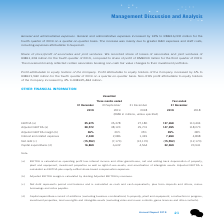According to Tencent's financial document, How is the adjusted EBITDA margin calculated? Adjusted EBITDA margin is calculated by dividing Adjusted EBITDA by revenues.. The document states: "(b) Adjusted EBITDA margin is calculated by dividing Adjusted EBITDA by revenues...." Also, What is adjusted EBITDA calculated as? Adjusted EBITDA is calculated as EBITDA plus equity-settled share-based compensation expenses.. The document states: "use assets, and amortisation of intangible assets. Adjusted EBITDA is calculated as EBITDA plus equity-settled share-based compensation expenses. (b) ..." Also, What does capital expenditures consist of? Capital expenditures consist of additions (excluding business combinations) to property, plant and equipment, construction in progress, investment properties, land use rights and intangible assets (excluding video and music contents, game licences and other contents).. The document states: "(d) Capital expenditures consist of additions (excluding business combinations) to property, plant and equipment, construction in progress, investment..." Also, can you calculate: What is the difference between EBITDA and Adjusted EBITDA for three months ended 31 December 2019? Based on the calculation: 38,572-35,675, the result is 2897 (in millions). This is based on the information: "Adjusted EBITDA (a) 38,572 38,123 29,701 147,395 118,273 EBITDA (a) 35,675 35,378 27,180 137,268 110,404..." The key data points involved are: 35,675, 38,572. Also, can you calculate: What is the difference between EBITDA and adjusted EBITDA for three months ended 30 September 2019? Based on the calculation: 38,123-35,378, the result is 2745 (in millions). This is based on the information: "Adjusted EBITDA (a) 38,572 38,123 29,701 147,395 118,273 EBITDA (a) 35,675 35,378 27,180 137,268 110,404..." The key data points involved are: 35,378, 38,123. Also, can you calculate: What is the difference between EBITDA and adjusted EBITDA for three months ended 31 December 2018? Based on the calculation: 29,701-27,180, the result is 2521 (in millions). This is based on the information: "Adjusted EBITDA (a) 38,572 38,123 29,701 147,395 118,273 EBITDA (a) 35,675 35,378 27,180 137,268 110,404..." The key data points involved are: 27,180, 29,701. 